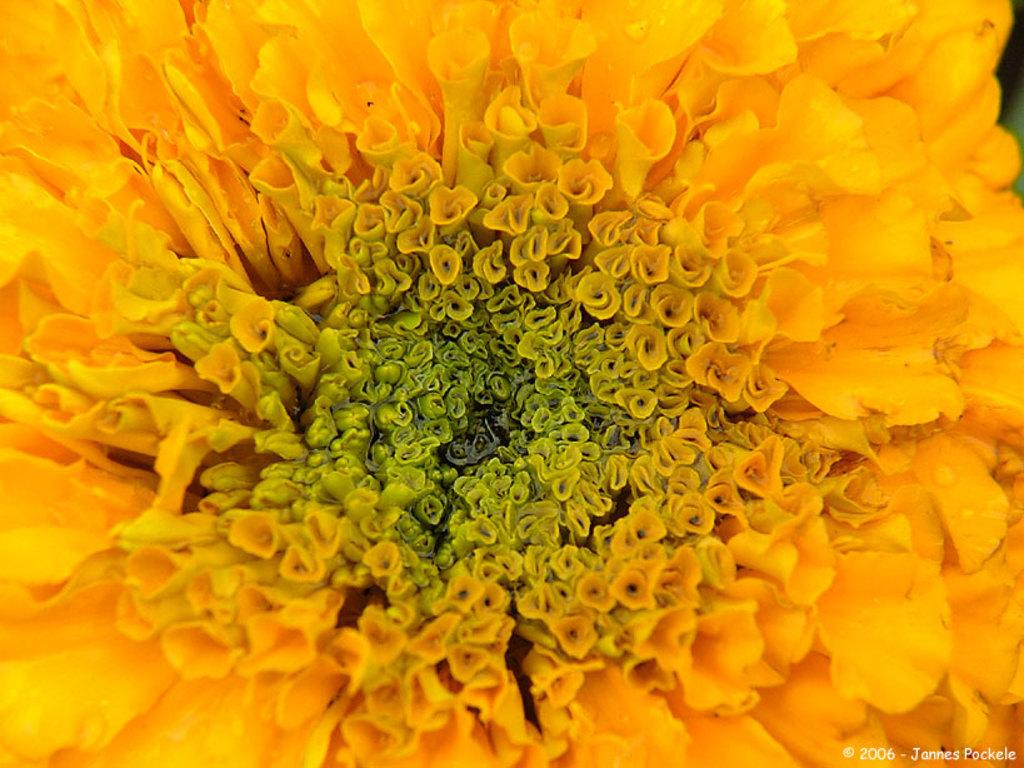What is the main subject of the image? There is a flower in the image. What type of crime is being committed by the army in space in the image? There is no reference to crime, the army, or space in the image, as it features a flower. 